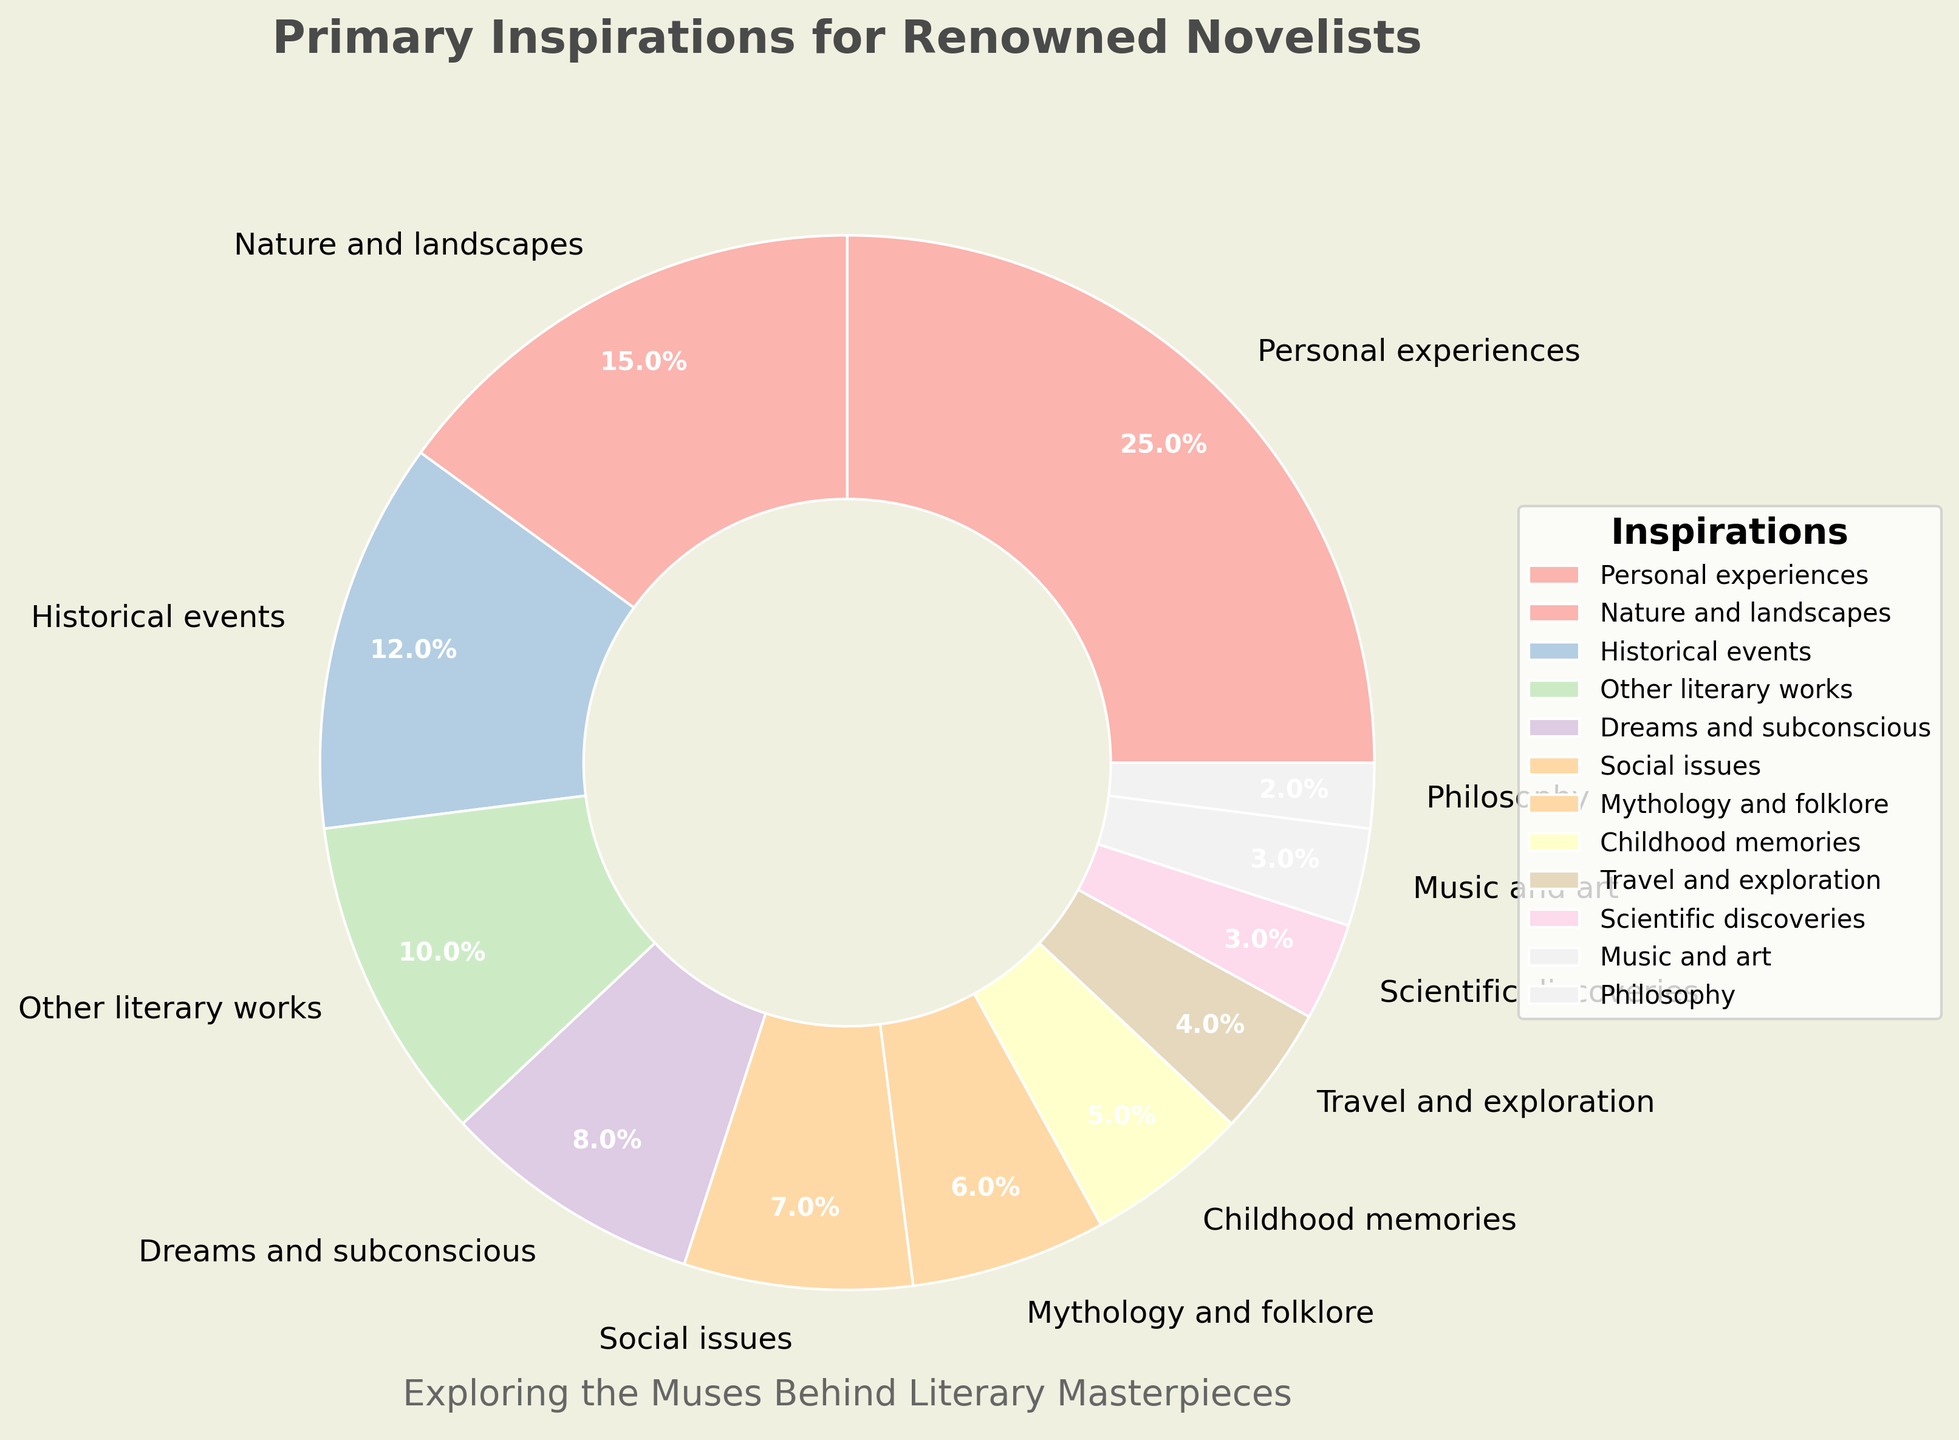What inspiration is the most frequently cited by novelists? Personal experiences have the largest wedge in the pie chart, indicating the highest percentage.
Answer: Personal experiences What percentage of novelists cite both "Nature and landscapes" and "Historical events" as their primary inspirations? Add the percentages for "Nature and landscapes" (15%) and "Historical events" (12%) to get the combined percentage. 15 + 12 = 27
Answer: 27% Is "Dreams and subconscious" cited more frequently than "Social issues"? Compare the percentages of "Dreams and subconscious" (8%) and "Social issues" (7%).
Answer: Yes What is the combined percentage of novelists who cite "Travel and exploration" and "Scientific discoveries" as their primary inspirations? Add the percentages for "Travel and exploration" (4%) and "Scientific discoveries" (3%) to get the combined percentage. 4 + 3 = 7
Answer: 7% Which has a greater percentage, "Mythology and folklore" or "Childhood memories"? Compare the percentages of "Mythology and folklore" (6%) and "Childhood memories" (5%).
Answer: Mythology and folklore How many inspirations are cited by at least 10% of the novelists? Identify inspirations with percentages 10% or greater: "Personal experiences" (25%), "Nature and landscapes" (15%), "Historical events" (12%), and "Other literary works" (10%). Count them. 4
Answer: 4 Do "Music and art" and "Philosophy" combined contribute more than "Social issues"? Add the percentages of "Music and art" (3%) and "Philosophy" (2%) and compare with "Social issues" (7%). 3 + 2 = 5, which is less than 7.
Answer: No Which inspiration occupies the smallest segment of the pie chart? "Philosophy" has the smallest segment with a percentage of 2%.
Answer: Philosophy If you combine "Historical events" and "Other literary works," does their total exceed "Personal experiences"? Add the percentages for "Historical events" (12%) and "Other literary works" (10%) and compare with "Personal experiences" (25%). 12 + 10 = 22, which is less than 25.
Answer: No 